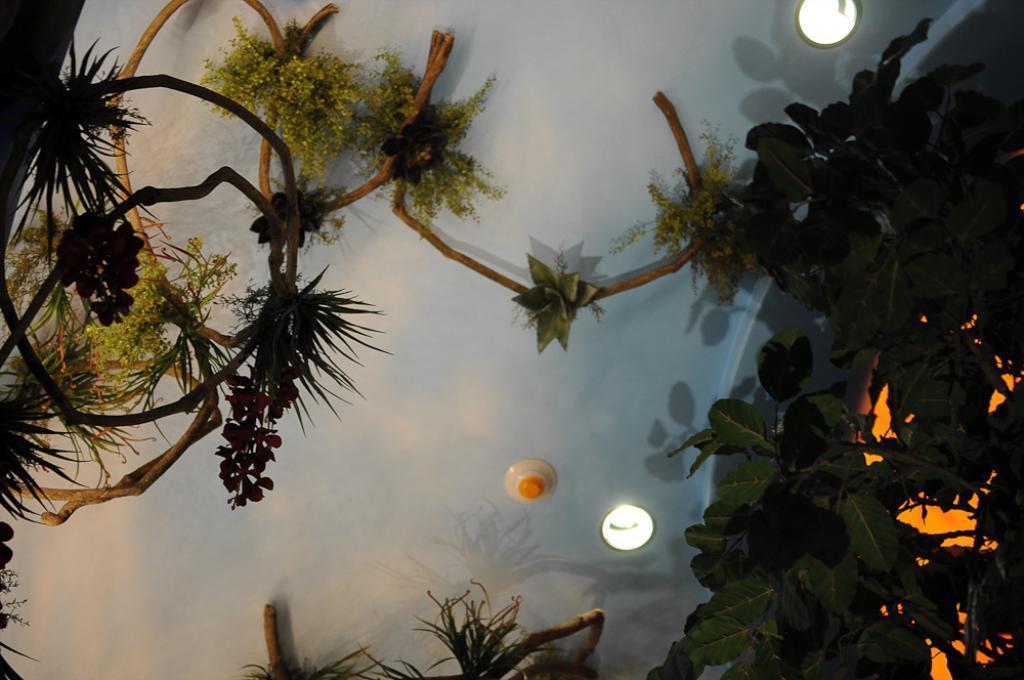Describe this image in one or two sentences. In this image we can see group of plants and some lights. 